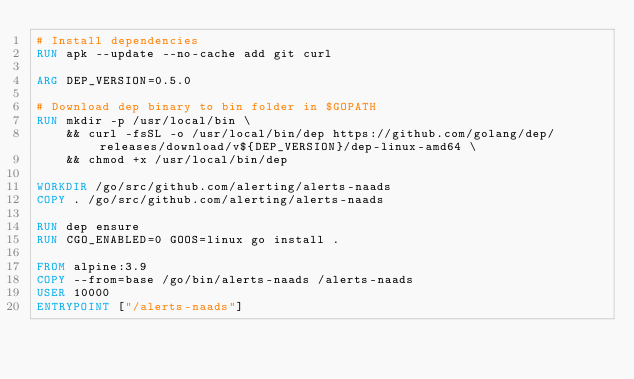<code> <loc_0><loc_0><loc_500><loc_500><_Dockerfile_># Install dependencies
RUN apk --update --no-cache add git curl

ARG DEP_VERSION=0.5.0

# Download dep binary to bin folder in $GOPATH
RUN mkdir -p /usr/local/bin \
    && curl -fsSL -o /usr/local/bin/dep https://github.com/golang/dep/releases/download/v${DEP_VERSION}/dep-linux-amd64 \
    && chmod +x /usr/local/bin/dep

WORKDIR /go/src/github.com/alerting/alerts-naads
COPY . /go/src/github.com/alerting/alerts-naads

RUN dep ensure
RUN CGO_ENABLED=0 GOOS=linux go install .

FROM alpine:3.9
COPY --from=base /go/bin/alerts-naads /alerts-naads
USER 10000
ENTRYPOINT ["/alerts-naads"]
</code> 